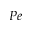<formula> <loc_0><loc_0><loc_500><loc_500>P e</formula> 